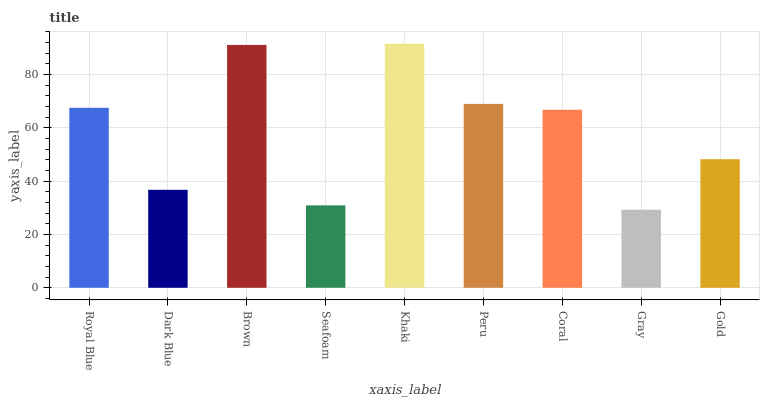Is Gray the minimum?
Answer yes or no. Yes. Is Khaki the maximum?
Answer yes or no. Yes. Is Dark Blue the minimum?
Answer yes or no. No. Is Dark Blue the maximum?
Answer yes or no. No. Is Royal Blue greater than Dark Blue?
Answer yes or no. Yes. Is Dark Blue less than Royal Blue?
Answer yes or no. Yes. Is Dark Blue greater than Royal Blue?
Answer yes or no. No. Is Royal Blue less than Dark Blue?
Answer yes or no. No. Is Coral the high median?
Answer yes or no. Yes. Is Coral the low median?
Answer yes or no. Yes. Is Khaki the high median?
Answer yes or no. No. Is Dark Blue the low median?
Answer yes or no. No. 